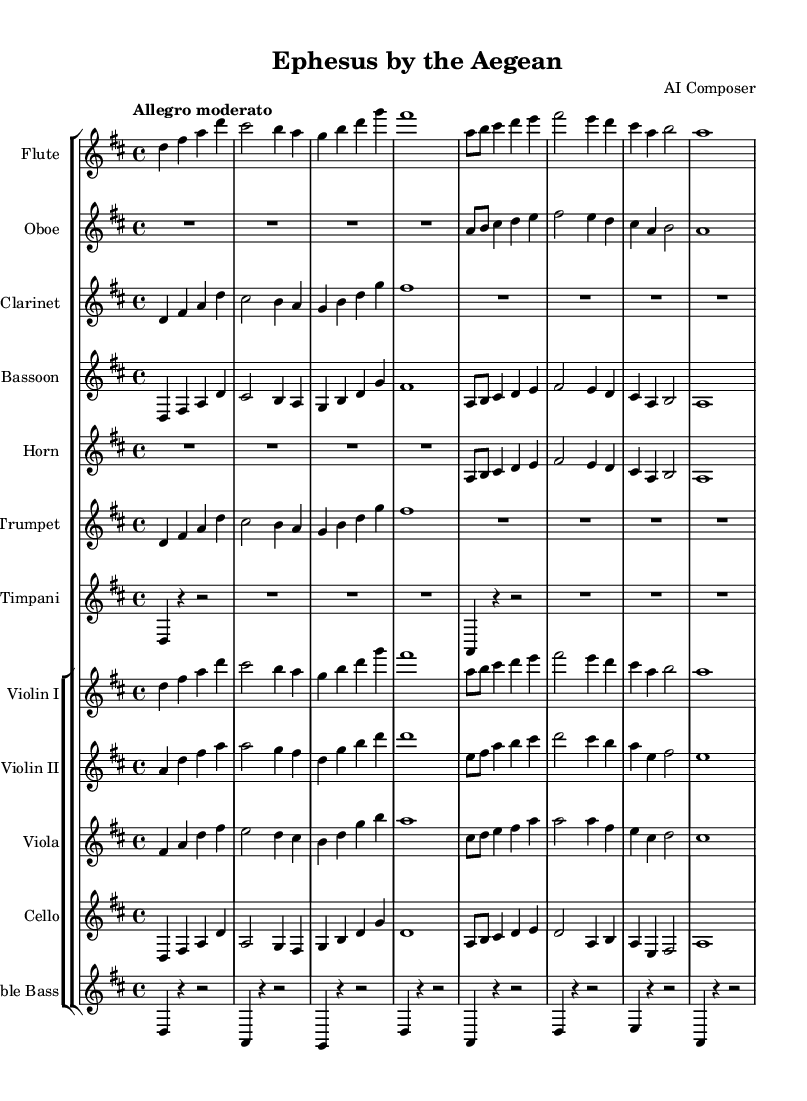What is the key signature of this music? The key signature is determined by the number of sharps or flats next to the clef. In this score, the key signature is D major, which has two sharps (F# and C#).
Answer: D major What is the time signature of this music? The time signature is found at the beginning of the staff, indicating how many beats are in a measure. Here, it is 4/4, meaning there are four beats per measure.
Answer: 4/4 What is the tempo marking in this music? The tempo marking indicates the speed of the piece and is typically found at the beginning of the score. This score indicates "Allegro moderato", which suggests a moderately fast tempo.
Answer: Allegro moderato How many instruments are there in this symphony? The number of instruments can be counted by reviewing the different staves in the score. There are 12 distinct instrument staves shown in the score.
Answer: 12 Which instrument has the lowest pitch range? To determine the instrument with the lowest pitch, we analyze the written notes on the staves. The Double Bass staff typically has the lowest pitch range compared to the other instruments, which are higher.
Answer: Double Bass What instruments are involved in the woodwind section? The woodwind section can be identified by looking at the specific instruments listed in the score. In this symphony, the woodwind instruments present are the Flute, Oboe, Clarinet, and Bassoon.
Answer: Flute, Oboe, Clarinet, Bassoon Which instrument plays a transposed part in this symphony? To find out which instruments are transposed, we look at the notes written for certain instruments. The Clarinet and Horn are transposed instruments as they show a different pitch than concert pitch.
Answer: Clarinet, Horn 